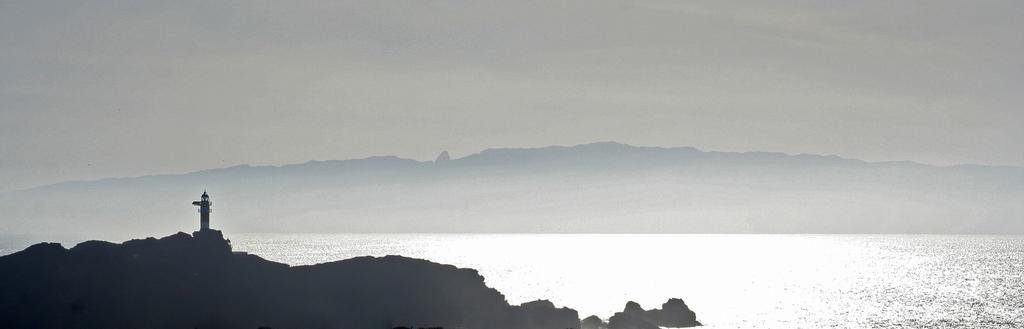What is the main feature of the dark area in the image? The main feature of the dark area is a tower house. What else can be found in the dark area? There are rocks in the dark area. What is visible in the image besides the dark area? Water is visible in the image. What can be seen in the background of the image? Hills are present in the background of the image, and the sky is plain and visible. How many trees are growing in the bucket in the image? There is no bucket or trees present in the image. 